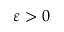Convert formula to latex. <formula><loc_0><loc_0><loc_500><loc_500>\varepsilon > 0</formula> 